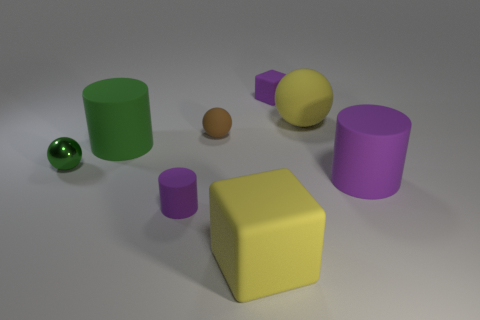Add 2 tiny matte blocks. How many objects exist? 10 Subtract all cubes. How many objects are left? 6 Subtract all large yellow cubes. Subtract all green spheres. How many objects are left? 6 Add 3 small rubber balls. How many small rubber balls are left? 4 Add 1 big purple things. How many big purple things exist? 2 Subtract 0 cyan spheres. How many objects are left? 8 